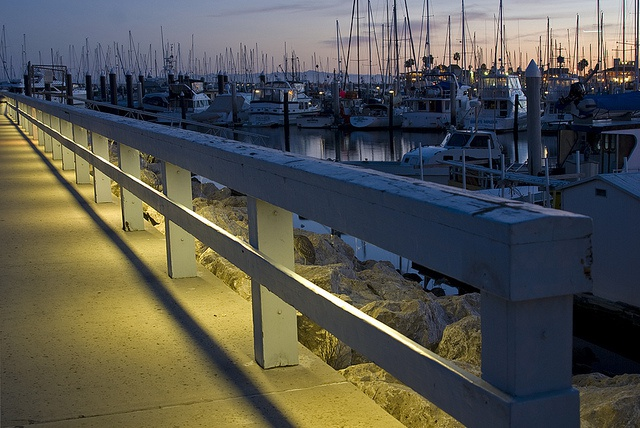Describe the objects in this image and their specific colors. I can see boat in gray, black, and navy tones, boat in gray, black, navy, and darkblue tones, boat in gray, navy, black, darkblue, and blue tones, boat in gray, navy, black, and darkblue tones, and boat in gray, black, navy, and darkblue tones in this image. 